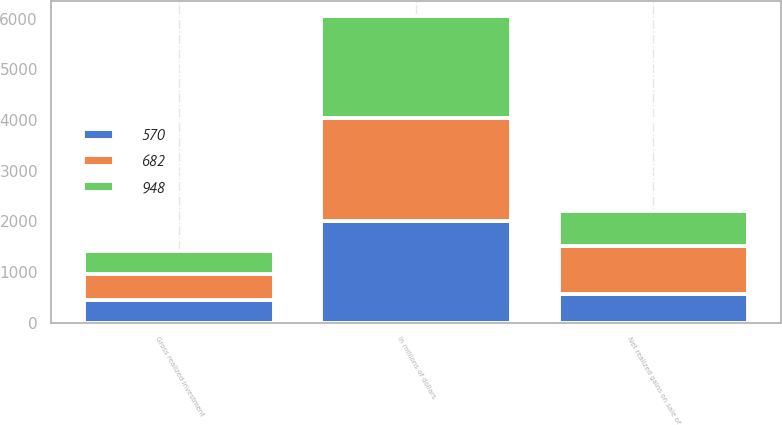<chart> <loc_0><loc_0><loc_500><loc_500><stacked_bar_chart><ecel><fcel>In millions of dollars<fcel>Gross realized investment<fcel>Net realized gains on sale of<nl><fcel>682<fcel>2016<fcel>512<fcel>948<nl><fcel>948<fcel>2015<fcel>442<fcel>682<nl><fcel>570<fcel>2014<fcel>450<fcel>570<nl></chart> 